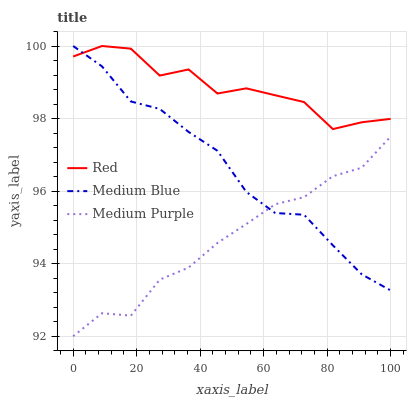Does Medium Purple have the minimum area under the curve?
Answer yes or no. Yes. Does Red have the maximum area under the curve?
Answer yes or no. Yes. Does Medium Blue have the minimum area under the curve?
Answer yes or no. No. Does Medium Blue have the maximum area under the curve?
Answer yes or no. No. Is Medium Blue the smoothest?
Answer yes or no. Yes. Is Red the roughest?
Answer yes or no. Yes. Is Red the smoothest?
Answer yes or no. No. Is Medium Blue the roughest?
Answer yes or no. No. Does Medium Blue have the lowest value?
Answer yes or no. No. Does Red have the highest value?
Answer yes or no. Yes. Is Medium Purple less than Red?
Answer yes or no. Yes. Is Red greater than Medium Purple?
Answer yes or no. Yes. Does Medium Blue intersect Red?
Answer yes or no. Yes. Is Medium Blue less than Red?
Answer yes or no. No. Is Medium Blue greater than Red?
Answer yes or no. No. Does Medium Purple intersect Red?
Answer yes or no. No. 